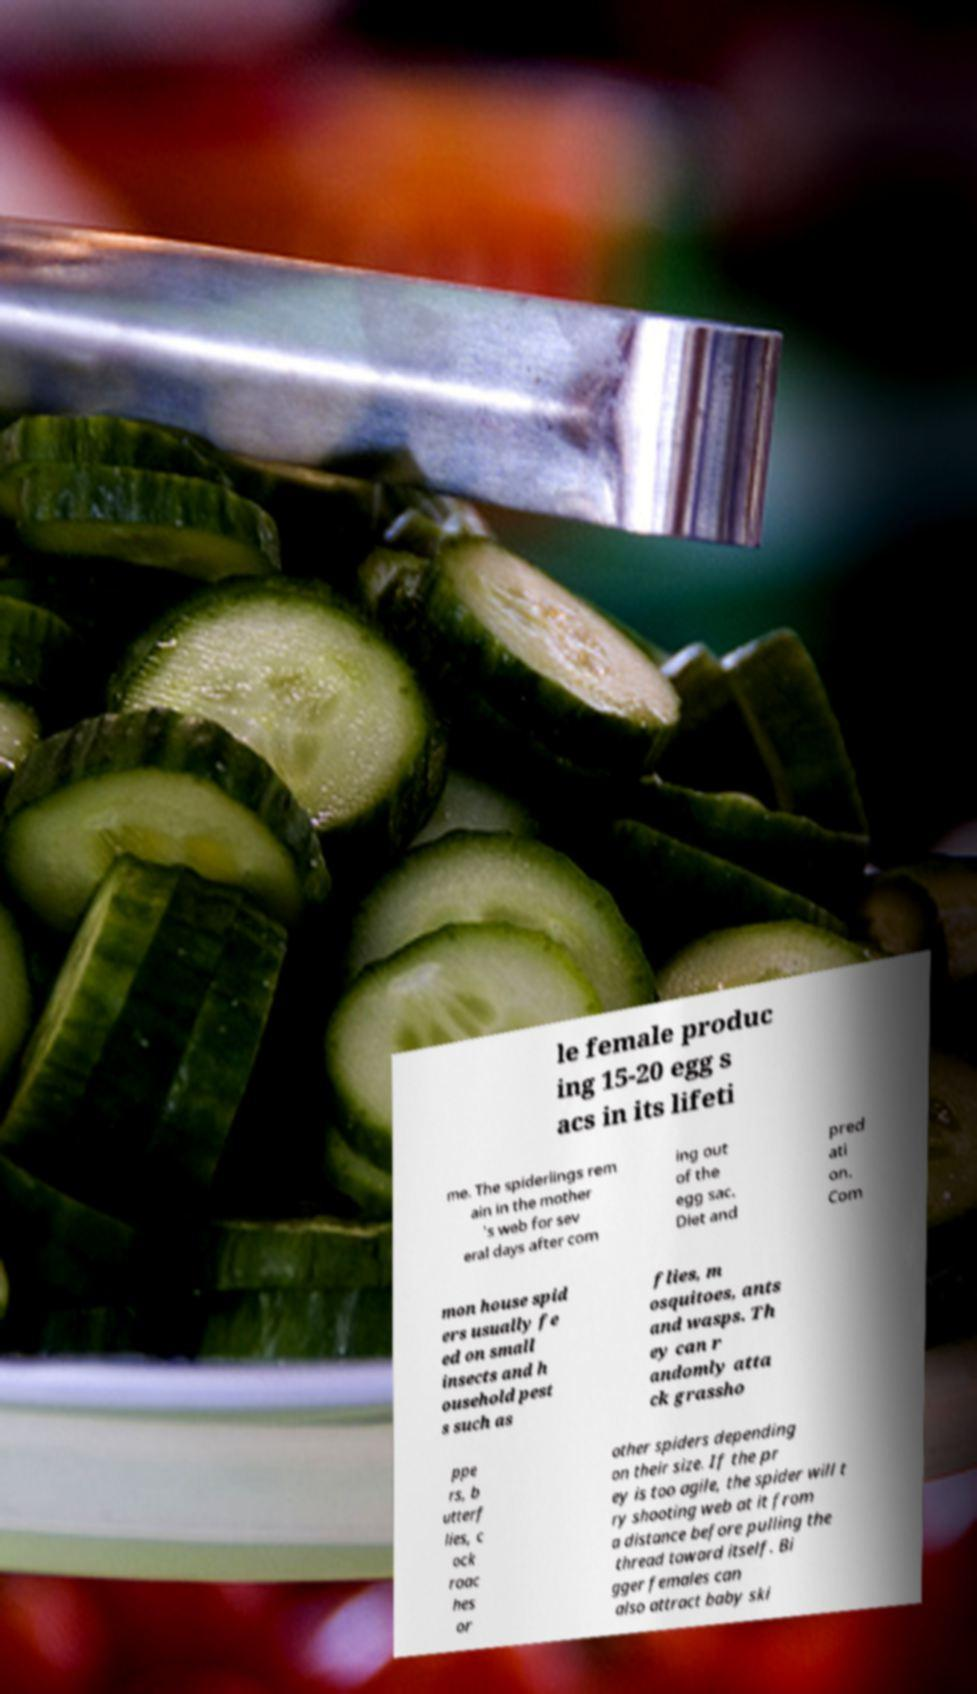Can you read and provide the text displayed in the image?This photo seems to have some interesting text. Can you extract and type it out for me? le female produc ing 15-20 egg s acs in its lifeti me. The spiderlings rem ain in the mother 's web for sev eral days after com ing out of the egg sac. Diet and pred ati on. Com mon house spid ers usually fe ed on small insects and h ousehold pest s such as flies, m osquitoes, ants and wasps. Th ey can r andomly atta ck grassho ppe rs, b utterf lies, c ock roac hes or other spiders depending on their size. If the pr ey is too agile, the spider will t ry shooting web at it from a distance before pulling the thread toward itself. Bi gger females can also attract baby ski 